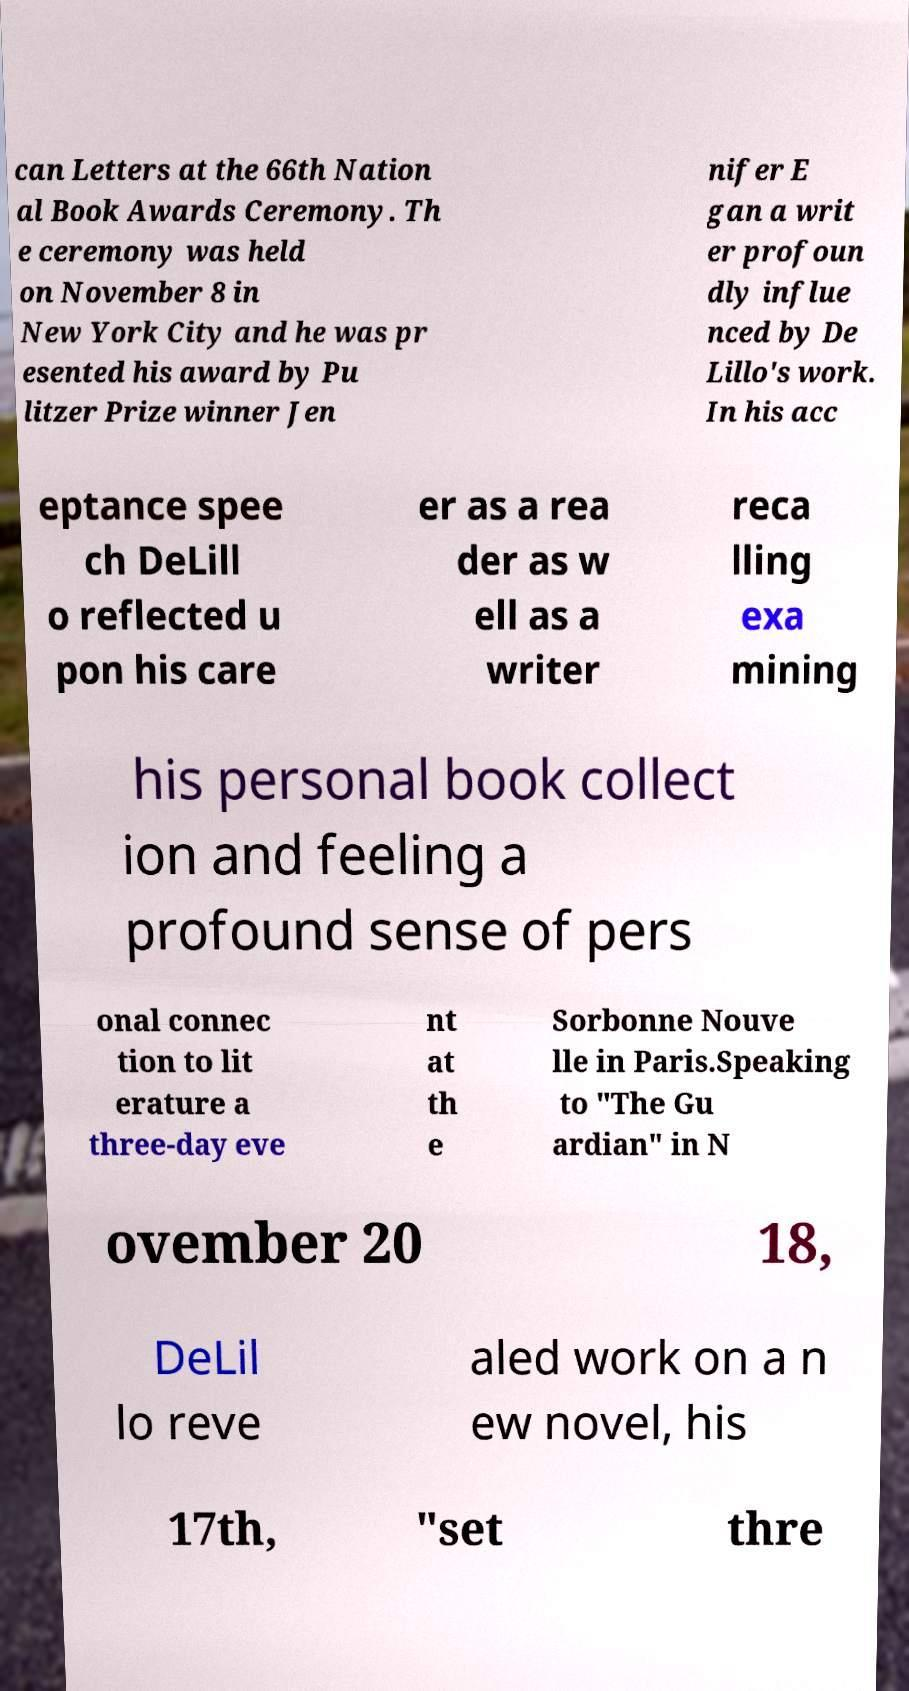Please read and relay the text visible in this image. What does it say? can Letters at the 66th Nation al Book Awards Ceremony. Th e ceremony was held on November 8 in New York City and he was pr esented his award by Pu litzer Prize winner Jen nifer E gan a writ er profoun dly influe nced by De Lillo's work. In his acc eptance spee ch DeLill o reflected u pon his care er as a rea der as w ell as a writer reca lling exa mining his personal book collect ion and feeling a profound sense of pers onal connec tion to lit erature a three-day eve nt at th e Sorbonne Nouve lle in Paris.Speaking to "The Gu ardian" in N ovember 20 18, DeLil lo reve aled work on a n ew novel, his 17th, "set thre 